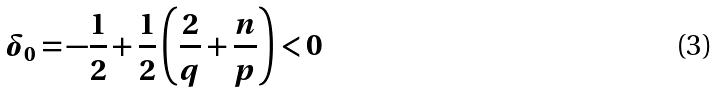Convert formula to latex. <formula><loc_0><loc_0><loc_500><loc_500>\delta _ { 0 } = - \frac { 1 } { 2 } + \frac { 1 } { 2 } \left ( \frac { 2 } { q } + \frac { n } { p } \right ) < 0</formula> 